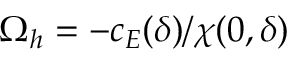Convert formula to latex. <formula><loc_0><loc_0><loc_500><loc_500>\Omega _ { h } = - c _ { E } ( \delta ) / \chi ( 0 , \delta )</formula> 